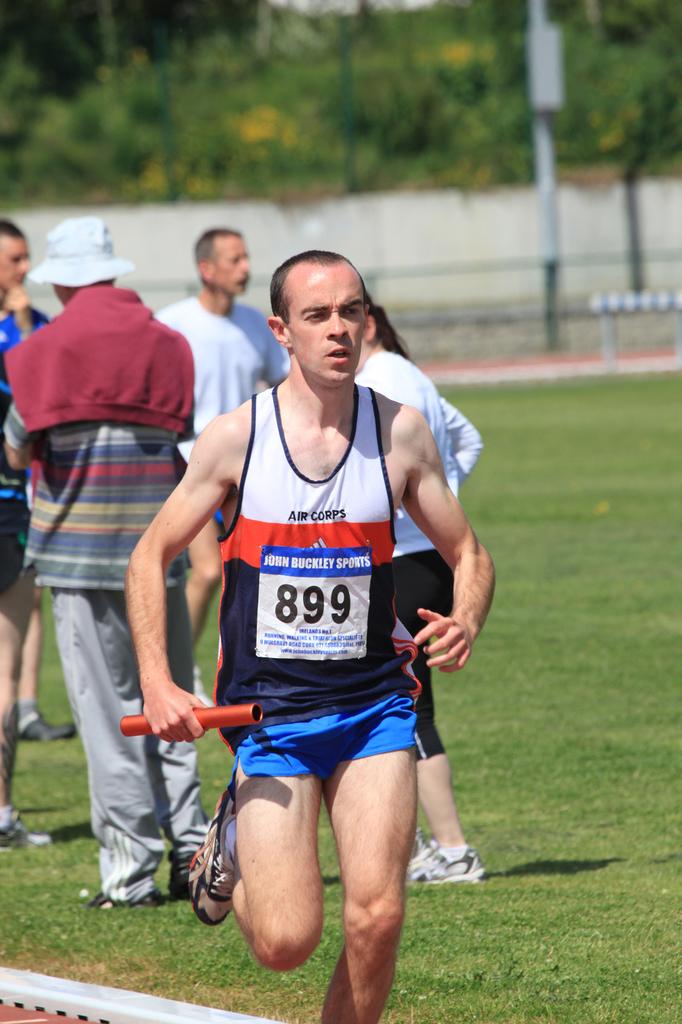What sports brand is mentioned on the front?
Provide a short and direct response. John buckley sports. 